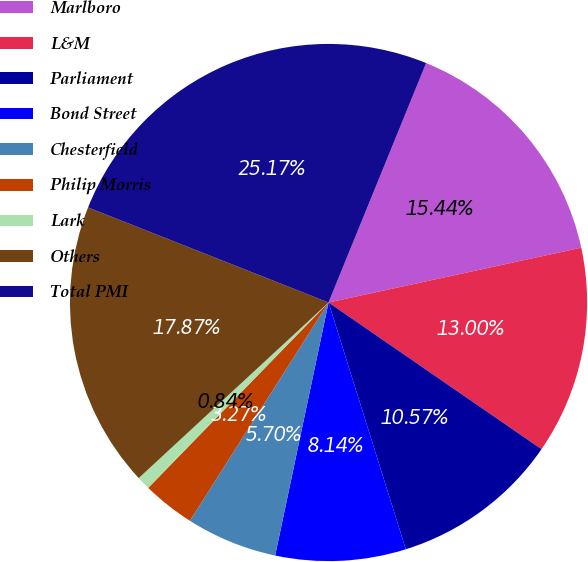Convert chart. <chart><loc_0><loc_0><loc_500><loc_500><pie_chart><fcel>Marlboro<fcel>L&M<fcel>Parliament<fcel>Bond Street<fcel>Chesterfield<fcel>Philip Morris<fcel>Lark<fcel>Others<fcel>Total PMI<nl><fcel>15.44%<fcel>13.0%<fcel>10.57%<fcel>8.14%<fcel>5.7%<fcel>3.27%<fcel>0.84%<fcel>17.87%<fcel>25.17%<nl></chart> 